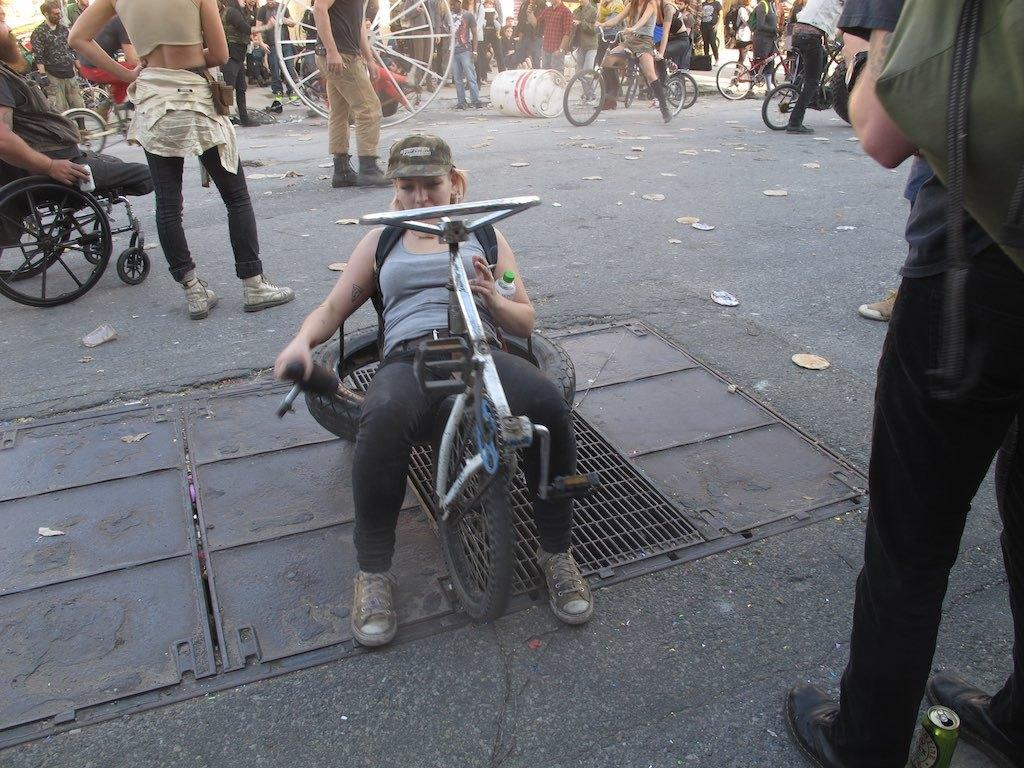Who is the main subject in the image? There is a woman in the image. What is the woman doing in the image? The woman is sitting on a wheel of a bicycle. What is the woman holding in her hand? The woman is holding something in her hand, but we cannot determine what it is from the image. What can be seen in the background of the image? There is a group of people in the background of the image, and they are sitting on wheelchairs and bicycles. What type of house is visible in the image? There is no house visible in the image. Can you solve the riddle that is written on the woman's shirt in the image? There is no riddle visible on the woman's shirt in the image. 